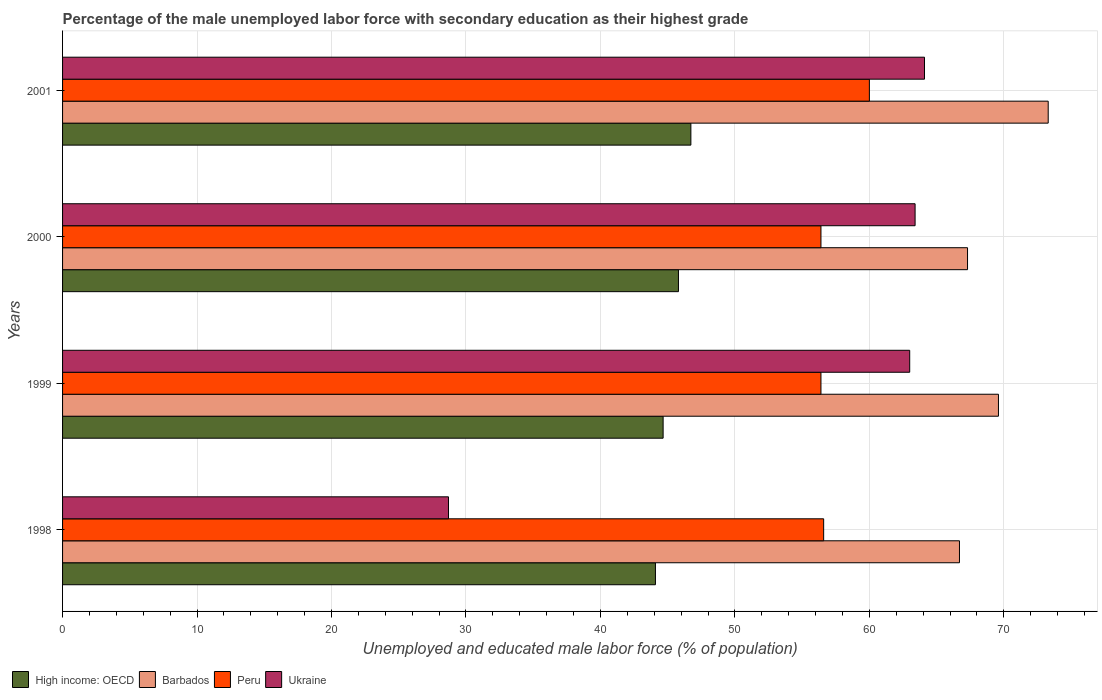How many different coloured bars are there?
Offer a terse response. 4. How many bars are there on the 1st tick from the top?
Offer a terse response. 4. How many bars are there on the 3rd tick from the bottom?
Keep it short and to the point. 4. What is the percentage of the unemployed male labor force with secondary education in Barbados in 1998?
Provide a succinct answer. 66.7. Across all years, what is the minimum percentage of the unemployed male labor force with secondary education in Ukraine?
Your response must be concise. 28.7. In which year was the percentage of the unemployed male labor force with secondary education in Barbados maximum?
Provide a succinct answer. 2001. In which year was the percentage of the unemployed male labor force with secondary education in Peru minimum?
Offer a very short reply. 1999. What is the total percentage of the unemployed male labor force with secondary education in Ukraine in the graph?
Your response must be concise. 219.2. What is the difference between the percentage of the unemployed male labor force with secondary education in Ukraine in 1998 and that in 1999?
Keep it short and to the point. -34.3. What is the difference between the percentage of the unemployed male labor force with secondary education in Ukraine in 2000 and the percentage of the unemployed male labor force with secondary education in Barbados in 1999?
Your answer should be compact. -6.2. What is the average percentage of the unemployed male labor force with secondary education in Barbados per year?
Provide a short and direct response. 69.23. In the year 1998, what is the difference between the percentage of the unemployed male labor force with secondary education in Ukraine and percentage of the unemployed male labor force with secondary education in Barbados?
Provide a succinct answer. -38. What is the ratio of the percentage of the unemployed male labor force with secondary education in Peru in 1999 to that in 2000?
Offer a very short reply. 1. Is the percentage of the unemployed male labor force with secondary education in Barbados in 1998 less than that in 2001?
Ensure brevity in your answer.  Yes. Is the difference between the percentage of the unemployed male labor force with secondary education in Ukraine in 2000 and 2001 greater than the difference between the percentage of the unemployed male labor force with secondary education in Barbados in 2000 and 2001?
Your answer should be very brief. Yes. What is the difference between the highest and the second highest percentage of the unemployed male labor force with secondary education in Peru?
Provide a short and direct response. 3.4. What is the difference between the highest and the lowest percentage of the unemployed male labor force with secondary education in Ukraine?
Provide a succinct answer. 35.4. In how many years, is the percentage of the unemployed male labor force with secondary education in Ukraine greater than the average percentage of the unemployed male labor force with secondary education in Ukraine taken over all years?
Provide a short and direct response. 3. Is it the case that in every year, the sum of the percentage of the unemployed male labor force with secondary education in Ukraine and percentage of the unemployed male labor force with secondary education in Barbados is greater than the sum of percentage of the unemployed male labor force with secondary education in High income: OECD and percentage of the unemployed male labor force with secondary education in Peru?
Your answer should be very brief. No. What does the 1st bar from the top in 1998 represents?
Keep it short and to the point. Ukraine. What does the 4th bar from the bottom in 2000 represents?
Keep it short and to the point. Ukraine. Is it the case that in every year, the sum of the percentage of the unemployed male labor force with secondary education in High income: OECD and percentage of the unemployed male labor force with secondary education in Peru is greater than the percentage of the unemployed male labor force with secondary education in Barbados?
Keep it short and to the point. Yes. Are all the bars in the graph horizontal?
Ensure brevity in your answer.  Yes. How many years are there in the graph?
Keep it short and to the point. 4. Are the values on the major ticks of X-axis written in scientific E-notation?
Offer a very short reply. No. Where does the legend appear in the graph?
Your response must be concise. Bottom left. What is the title of the graph?
Your answer should be compact. Percentage of the male unemployed labor force with secondary education as their highest grade. What is the label or title of the X-axis?
Ensure brevity in your answer.  Unemployed and educated male labor force (% of population). What is the label or title of the Y-axis?
Offer a very short reply. Years. What is the Unemployed and educated male labor force (% of population) in High income: OECD in 1998?
Offer a very short reply. 44.09. What is the Unemployed and educated male labor force (% of population) of Barbados in 1998?
Offer a very short reply. 66.7. What is the Unemployed and educated male labor force (% of population) of Peru in 1998?
Your response must be concise. 56.6. What is the Unemployed and educated male labor force (% of population) of Ukraine in 1998?
Offer a very short reply. 28.7. What is the Unemployed and educated male labor force (% of population) in High income: OECD in 1999?
Ensure brevity in your answer.  44.66. What is the Unemployed and educated male labor force (% of population) in Barbados in 1999?
Offer a very short reply. 69.6. What is the Unemployed and educated male labor force (% of population) of Peru in 1999?
Give a very brief answer. 56.4. What is the Unemployed and educated male labor force (% of population) of High income: OECD in 2000?
Offer a very short reply. 45.8. What is the Unemployed and educated male labor force (% of population) in Barbados in 2000?
Offer a terse response. 67.3. What is the Unemployed and educated male labor force (% of population) of Peru in 2000?
Provide a succinct answer. 56.4. What is the Unemployed and educated male labor force (% of population) in Ukraine in 2000?
Offer a terse response. 63.4. What is the Unemployed and educated male labor force (% of population) in High income: OECD in 2001?
Offer a terse response. 46.73. What is the Unemployed and educated male labor force (% of population) in Barbados in 2001?
Give a very brief answer. 73.3. What is the Unemployed and educated male labor force (% of population) of Ukraine in 2001?
Your response must be concise. 64.1. Across all years, what is the maximum Unemployed and educated male labor force (% of population) in High income: OECD?
Give a very brief answer. 46.73. Across all years, what is the maximum Unemployed and educated male labor force (% of population) in Barbados?
Keep it short and to the point. 73.3. Across all years, what is the maximum Unemployed and educated male labor force (% of population) in Ukraine?
Your answer should be very brief. 64.1. Across all years, what is the minimum Unemployed and educated male labor force (% of population) of High income: OECD?
Provide a succinct answer. 44.09. Across all years, what is the minimum Unemployed and educated male labor force (% of population) of Barbados?
Your answer should be compact. 66.7. Across all years, what is the minimum Unemployed and educated male labor force (% of population) of Peru?
Give a very brief answer. 56.4. Across all years, what is the minimum Unemployed and educated male labor force (% of population) of Ukraine?
Provide a short and direct response. 28.7. What is the total Unemployed and educated male labor force (% of population) in High income: OECD in the graph?
Your answer should be compact. 181.28. What is the total Unemployed and educated male labor force (% of population) in Barbados in the graph?
Your answer should be very brief. 276.9. What is the total Unemployed and educated male labor force (% of population) of Peru in the graph?
Give a very brief answer. 229.4. What is the total Unemployed and educated male labor force (% of population) of Ukraine in the graph?
Your answer should be very brief. 219.2. What is the difference between the Unemployed and educated male labor force (% of population) of High income: OECD in 1998 and that in 1999?
Offer a very short reply. -0.57. What is the difference between the Unemployed and educated male labor force (% of population) of Barbados in 1998 and that in 1999?
Ensure brevity in your answer.  -2.9. What is the difference between the Unemployed and educated male labor force (% of population) in Ukraine in 1998 and that in 1999?
Your answer should be compact. -34.3. What is the difference between the Unemployed and educated male labor force (% of population) of High income: OECD in 1998 and that in 2000?
Give a very brief answer. -1.71. What is the difference between the Unemployed and educated male labor force (% of population) of Barbados in 1998 and that in 2000?
Make the answer very short. -0.6. What is the difference between the Unemployed and educated male labor force (% of population) of Ukraine in 1998 and that in 2000?
Give a very brief answer. -34.7. What is the difference between the Unemployed and educated male labor force (% of population) in High income: OECD in 1998 and that in 2001?
Keep it short and to the point. -2.63. What is the difference between the Unemployed and educated male labor force (% of population) in Ukraine in 1998 and that in 2001?
Make the answer very short. -35.4. What is the difference between the Unemployed and educated male labor force (% of population) of High income: OECD in 1999 and that in 2000?
Make the answer very short. -1.14. What is the difference between the Unemployed and educated male labor force (% of population) in Barbados in 1999 and that in 2000?
Your answer should be compact. 2.3. What is the difference between the Unemployed and educated male labor force (% of population) in Ukraine in 1999 and that in 2000?
Offer a terse response. -0.4. What is the difference between the Unemployed and educated male labor force (% of population) in High income: OECD in 1999 and that in 2001?
Keep it short and to the point. -2.06. What is the difference between the Unemployed and educated male labor force (% of population) of Barbados in 1999 and that in 2001?
Your answer should be very brief. -3.7. What is the difference between the Unemployed and educated male labor force (% of population) in Peru in 1999 and that in 2001?
Give a very brief answer. -3.6. What is the difference between the Unemployed and educated male labor force (% of population) of Ukraine in 1999 and that in 2001?
Offer a terse response. -1.1. What is the difference between the Unemployed and educated male labor force (% of population) in High income: OECD in 2000 and that in 2001?
Keep it short and to the point. -0.92. What is the difference between the Unemployed and educated male labor force (% of population) of Barbados in 2000 and that in 2001?
Provide a succinct answer. -6. What is the difference between the Unemployed and educated male labor force (% of population) of High income: OECD in 1998 and the Unemployed and educated male labor force (% of population) of Barbados in 1999?
Give a very brief answer. -25.51. What is the difference between the Unemployed and educated male labor force (% of population) of High income: OECD in 1998 and the Unemployed and educated male labor force (% of population) of Peru in 1999?
Give a very brief answer. -12.31. What is the difference between the Unemployed and educated male labor force (% of population) of High income: OECD in 1998 and the Unemployed and educated male labor force (% of population) of Ukraine in 1999?
Keep it short and to the point. -18.91. What is the difference between the Unemployed and educated male labor force (% of population) of Barbados in 1998 and the Unemployed and educated male labor force (% of population) of Ukraine in 1999?
Offer a terse response. 3.7. What is the difference between the Unemployed and educated male labor force (% of population) in Peru in 1998 and the Unemployed and educated male labor force (% of population) in Ukraine in 1999?
Your answer should be compact. -6.4. What is the difference between the Unemployed and educated male labor force (% of population) of High income: OECD in 1998 and the Unemployed and educated male labor force (% of population) of Barbados in 2000?
Provide a short and direct response. -23.21. What is the difference between the Unemployed and educated male labor force (% of population) in High income: OECD in 1998 and the Unemployed and educated male labor force (% of population) in Peru in 2000?
Ensure brevity in your answer.  -12.31. What is the difference between the Unemployed and educated male labor force (% of population) in High income: OECD in 1998 and the Unemployed and educated male labor force (% of population) in Ukraine in 2000?
Offer a very short reply. -19.31. What is the difference between the Unemployed and educated male labor force (% of population) in Barbados in 1998 and the Unemployed and educated male labor force (% of population) in Peru in 2000?
Keep it short and to the point. 10.3. What is the difference between the Unemployed and educated male labor force (% of population) in High income: OECD in 1998 and the Unemployed and educated male labor force (% of population) in Barbados in 2001?
Offer a terse response. -29.21. What is the difference between the Unemployed and educated male labor force (% of population) of High income: OECD in 1998 and the Unemployed and educated male labor force (% of population) of Peru in 2001?
Your response must be concise. -15.91. What is the difference between the Unemployed and educated male labor force (% of population) of High income: OECD in 1998 and the Unemployed and educated male labor force (% of population) of Ukraine in 2001?
Your answer should be compact. -20.01. What is the difference between the Unemployed and educated male labor force (% of population) in Barbados in 1998 and the Unemployed and educated male labor force (% of population) in Peru in 2001?
Your response must be concise. 6.7. What is the difference between the Unemployed and educated male labor force (% of population) of Peru in 1998 and the Unemployed and educated male labor force (% of population) of Ukraine in 2001?
Give a very brief answer. -7.5. What is the difference between the Unemployed and educated male labor force (% of population) of High income: OECD in 1999 and the Unemployed and educated male labor force (% of population) of Barbados in 2000?
Ensure brevity in your answer.  -22.64. What is the difference between the Unemployed and educated male labor force (% of population) in High income: OECD in 1999 and the Unemployed and educated male labor force (% of population) in Peru in 2000?
Offer a terse response. -11.74. What is the difference between the Unemployed and educated male labor force (% of population) of High income: OECD in 1999 and the Unemployed and educated male labor force (% of population) of Ukraine in 2000?
Give a very brief answer. -18.74. What is the difference between the Unemployed and educated male labor force (% of population) in Peru in 1999 and the Unemployed and educated male labor force (% of population) in Ukraine in 2000?
Offer a very short reply. -7. What is the difference between the Unemployed and educated male labor force (% of population) of High income: OECD in 1999 and the Unemployed and educated male labor force (% of population) of Barbados in 2001?
Provide a succinct answer. -28.64. What is the difference between the Unemployed and educated male labor force (% of population) in High income: OECD in 1999 and the Unemployed and educated male labor force (% of population) in Peru in 2001?
Ensure brevity in your answer.  -15.34. What is the difference between the Unemployed and educated male labor force (% of population) in High income: OECD in 1999 and the Unemployed and educated male labor force (% of population) in Ukraine in 2001?
Make the answer very short. -19.44. What is the difference between the Unemployed and educated male labor force (% of population) of Barbados in 1999 and the Unemployed and educated male labor force (% of population) of Peru in 2001?
Provide a succinct answer. 9.6. What is the difference between the Unemployed and educated male labor force (% of population) of Peru in 1999 and the Unemployed and educated male labor force (% of population) of Ukraine in 2001?
Ensure brevity in your answer.  -7.7. What is the difference between the Unemployed and educated male labor force (% of population) of High income: OECD in 2000 and the Unemployed and educated male labor force (% of population) of Barbados in 2001?
Ensure brevity in your answer.  -27.5. What is the difference between the Unemployed and educated male labor force (% of population) in High income: OECD in 2000 and the Unemployed and educated male labor force (% of population) in Peru in 2001?
Your answer should be compact. -14.2. What is the difference between the Unemployed and educated male labor force (% of population) in High income: OECD in 2000 and the Unemployed and educated male labor force (% of population) in Ukraine in 2001?
Offer a terse response. -18.3. What is the difference between the Unemployed and educated male labor force (% of population) in Barbados in 2000 and the Unemployed and educated male labor force (% of population) in Peru in 2001?
Ensure brevity in your answer.  7.3. What is the difference between the Unemployed and educated male labor force (% of population) in Peru in 2000 and the Unemployed and educated male labor force (% of population) in Ukraine in 2001?
Provide a short and direct response. -7.7. What is the average Unemployed and educated male labor force (% of population) in High income: OECD per year?
Provide a succinct answer. 45.32. What is the average Unemployed and educated male labor force (% of population) of Barbados per year?
Your answer should be compact. 69.22. What is the average Unemployed and educated male labor force (% of population) of Peru per year?
Your answer should be compact. 57.35. What is the average Unemployed and educated male labor force (% of population) in Ukraine per year?
Your response must be concise. 54.8. In the year 1998, what is the difference between the Unemployed and educated male labor force (% of population) in High income: OECD and Unemployed and educated male labor force (% of population) in Barbados?
Offer a terse response. -22.61. In the year 1998, what is the difference between the Unemployed and educated male labor force (% of population) of High income: OECD and Unemployed and educated male labor force (% of population) of Peru?
Offer a terse response. -12.51. In the year 1998, what is the difference between the Unemployed and educated male labor force (% of population) in High income: OECD and Unemployed and educated male labor force (% of population) in Ukraine?
Make the answer very short. 15.39. In the year 1998, what is the difference between the Unemployed and educated male labor force (% of population) in Barbados and Unemployed and educated male labor force (% of population) in Ukraine?
Your answer should be very brief. 38. In the year 1998, what is the difference between the Unemployed and educated male labor force (% of population) of Peru and Unemployed and educated male labor force (% of population) of Ukraine?
Provide a succinct answer. 27.9. In the year 1999, what is the difference between the Unemployed and educated male labor force (% of population) of High income: OECD and Unemployed and educated male labor force (% of population) of Barbados?
Provide a short and direct response. -24.94. In the year 1999, what is the difference between the Unemployed and educated male labor force (% of population) in High income: OECD and Unemployed and educated male labor force (% of population) in Peru?
Ensure brevity in your answer.  -11.74. In the year 1999, what is the difference between the Unemployed and educated male labor force (% of population) of High income: OECD and Unemployed and educated male labor force (% of population) of Ukraine?
Provide a short and direct response. -18.34. In the year 1999, what is the difference between the Unemployed and educated male labor force (% of population) in Barbados and Unemployed and educated male labor force (% of population) in Peru?
Offer a terse response. 13.2. In the year 2000, what is the difference between the Unemployed and educated male labor force (% of population) of High income: OECD and Unemployed and educated male labor force (% of population) of Barbados?
Offer a very short reply. -21.5. In the year 2000, what is the difference between the Unemployed and educated male labor force (% of population) in High income: OECD and Unemployed and educated male labor force (% of population) in Peru?
Make the answer very short. -10.6. In the year 2000, what is the difference between the Unemployed and educated male labor force (% of population) of High income: OECD and Unemployed and educated male labor force (% of population) of Ukraine?
Offer a terse response. -17.6. In the year 2000, what is the difference between the Unemployed and educated male labor force (% of population) of Peru and Unemployed and educated male labor force (% of population) of Ukraine?
Your answer should be compact. -7. In the year 2001, what is the difference between the Unemployed and educated male labor force (% of population) in High income: OECD and Unemployed and educated male labor force (% of population) in Barbados?
Your answer should be very brief. -26.57. In the year 2001, what is the difference between the Unemployed and educated male labor force (% of population) of High income: OECD and Unemployed and educated male labor force (% of population) of Peru?
Give a very brief answer. -13.27. In the year 2001, what is the difference between the Unemployed and educated male labor force (% of population) in High income: OECD and Unemployed and educated male labor force (% of population) in Ukraine?
Provide a succinct answer. -17.37. In the year 2001, what is the difference between the Unemployed and educated male labor force (% of population) in Barbados and Unemployed and educated male labor force (% of population) in Ukraine?
Ensure brevity in your answer.  9.2. What is the ratio of the Unemployed and educated male labor force (% of population) of High income: OECD in 1998 to that in 1999?
Make the answer very short. 0.99. What is the ratio of the Unemployed and educated male labor force (% of population) of Ukraine in 1998 to that in 1999?
Give a very brief answer. 0.46. What is the ratio of the Unemployed and educated male labor force (% of population) of High income: OECD in 1998 to that in 2000?
Keep it short and to the point. 0.96. What is the ratio of the Unemployed and educated male labor force (% of population) in Barbados in 1998 to that in 2000?
Keep it short and to the point. 0.99. What is the ratio of the Unemployed and educated male labor force (% of population) in Ukraine in 1998 to that in 2000?
Make the answer very short. 0.45. What is the ratio of the Unemployed and educated male labor force (% of population) of High income: OECD in 1998 to that in 2001?
Your response must be concise. 0.94. What is the ratio of the Unemployed and educated male labor force (% of population) of Barbados in 1998 to that in 2001?
Offer a terse response. 0.91. What is the ratio of the Unemployed and educated male labor force (% of population) in Peru in 1998 to that in 2001?
Offer a terse response. 0.94. What is the ratio of the Unemployed and educated male labor force (% of population) in Ukraine in 1998 to that in 2001?
Provide a succinct answer. 0.45. What is the ratio of the Unemployed and educated male labor force (% of population) of High income: OECD in 1999 to that in 2000?
Your response must be concise. 0.98. What is the ratio of the Unemployed and educated male labor force (% of population) of Barbados in 1999 to that in 2000?
Provide a succinct answer. 1.03. What is the ratio of the Unemployed and educated male labor force (% of population) of Peru in 1999 to that in 2000?
Offer a terse response. 1. What is the ratio of the Unemployed and educated male labor force (% of population) of High income: OECD in 1999 to that in 2001?
Ensure brevity in your answer.  0.96. What is the ratio of the Unemployed and educated male labor force (% of population) of Barbados in 1999 to that in 2001?
Offer a very short reply. 0.95. What is the ratio of the Unemployed and educated male labor force (% of population) in Peru in 1999 to that in 2001?
Offer a terse response. 0.94. What is the ratio of the Unemployed and educated male labor force (% of population) in Ukraine in 1999 to that in 2001?
Provide a short and direct response. 0.98. What is the ratio of the Unemployed and educated male labor force (% of population) in High income: OECD in 2000 to that in 2001?
Your response must be concise. 0.98. What is the ratio of the Unemployed and educated male labor force (% of population) of Barbados in 2000 to that in 2001?
Give a very brief answer. 0.92. What is the ratio of the Unemployed and educated male labor force (% of population) in Peru in 2000 to that in 2001?
Keep it short and to the point. 0.94. What is the ratio of the Unemployed and educated male labor force (% of population) in Ukraine in 2000 to that in 2001?
Make the answer very short. 0.99. What is the difference between the highest and the second highest Unemployed and educated male labor force (% of population) of High income: OECD?
Provide a short and direct response. 0.92. What is the difference between the highest and the second highest Unemployed and educated male labor force (% of population) of Peru?
Make the answer very short. 3.4. What is the difference between the highest and the second highest Unemployed and educated male labor force (% of population) in Ukraine?
Ensure brevity in your answer.  0.7. What is the difference between the highest and the lowest Unemployed and educated male labor force (% of population) in High income: OECD?
Provide a succinct answer. 2.63. What is the difference between the highest and the lowest Unemployed and educated male labor force (% of population) in Peru?
Your answer should be very brief. 3.6. What is the difference between the highest and the lowest Unemployed and educated male labor force (% of population) in Ukraine?
Provide a short and direct response. 35.4. 